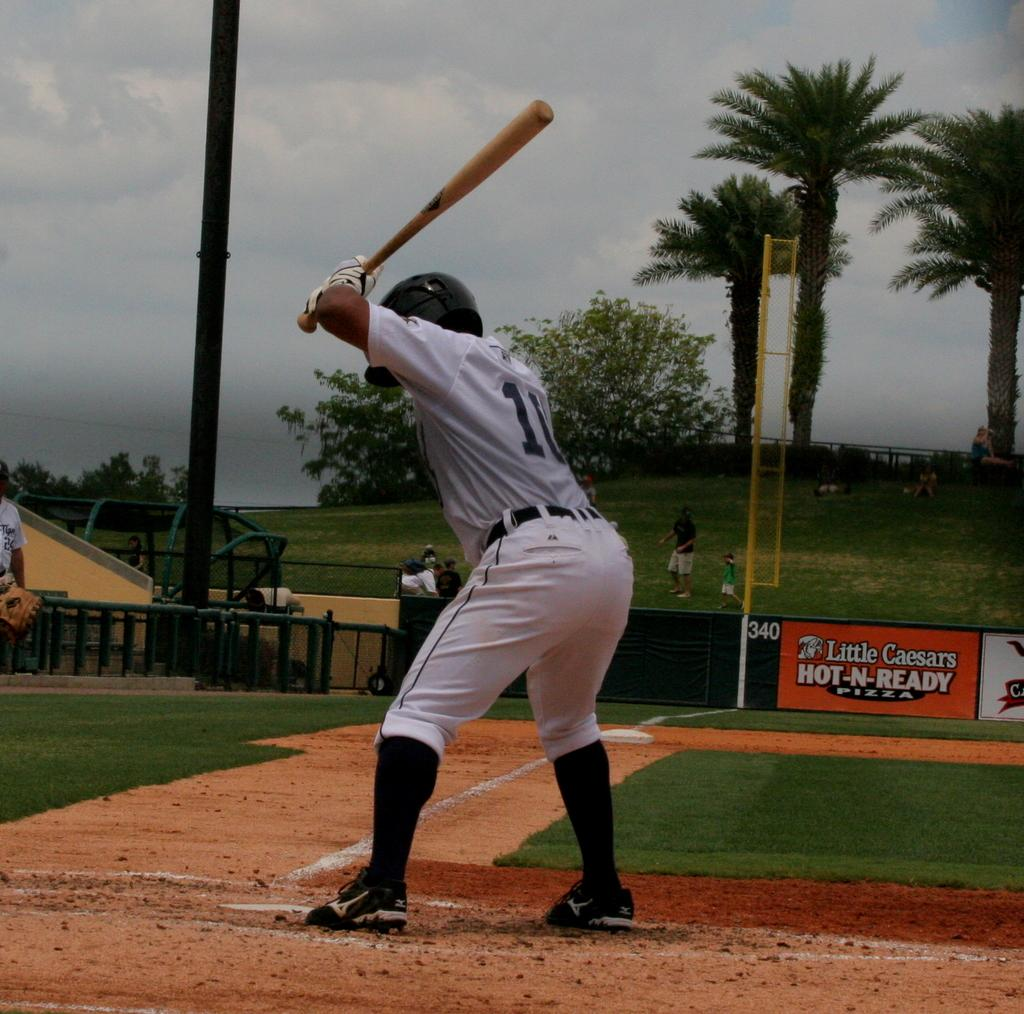<image>
Describe the image concisely. A base ball player stands waiting to hit the ball with a banner for little ceasers hot n ready pizza behind him 